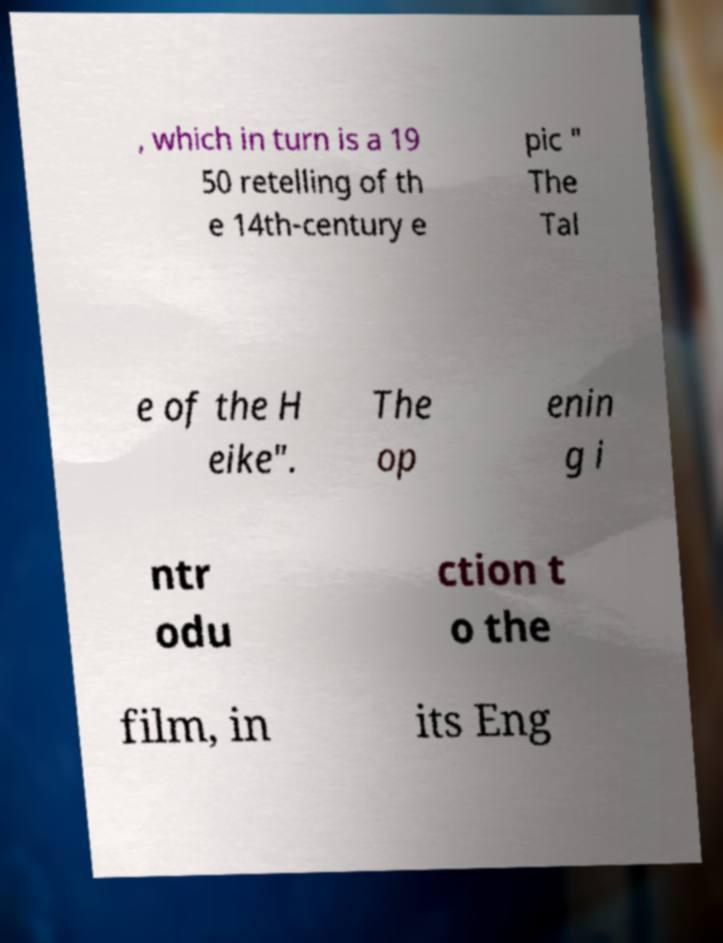Please read and relay the text visible in this image. What does it say? , which in turn is a 19 50 retelling of th e 14th-century e pic " The Tal e of the H eike". The op enin g i ntr odu ction t o the film, in its Eng 